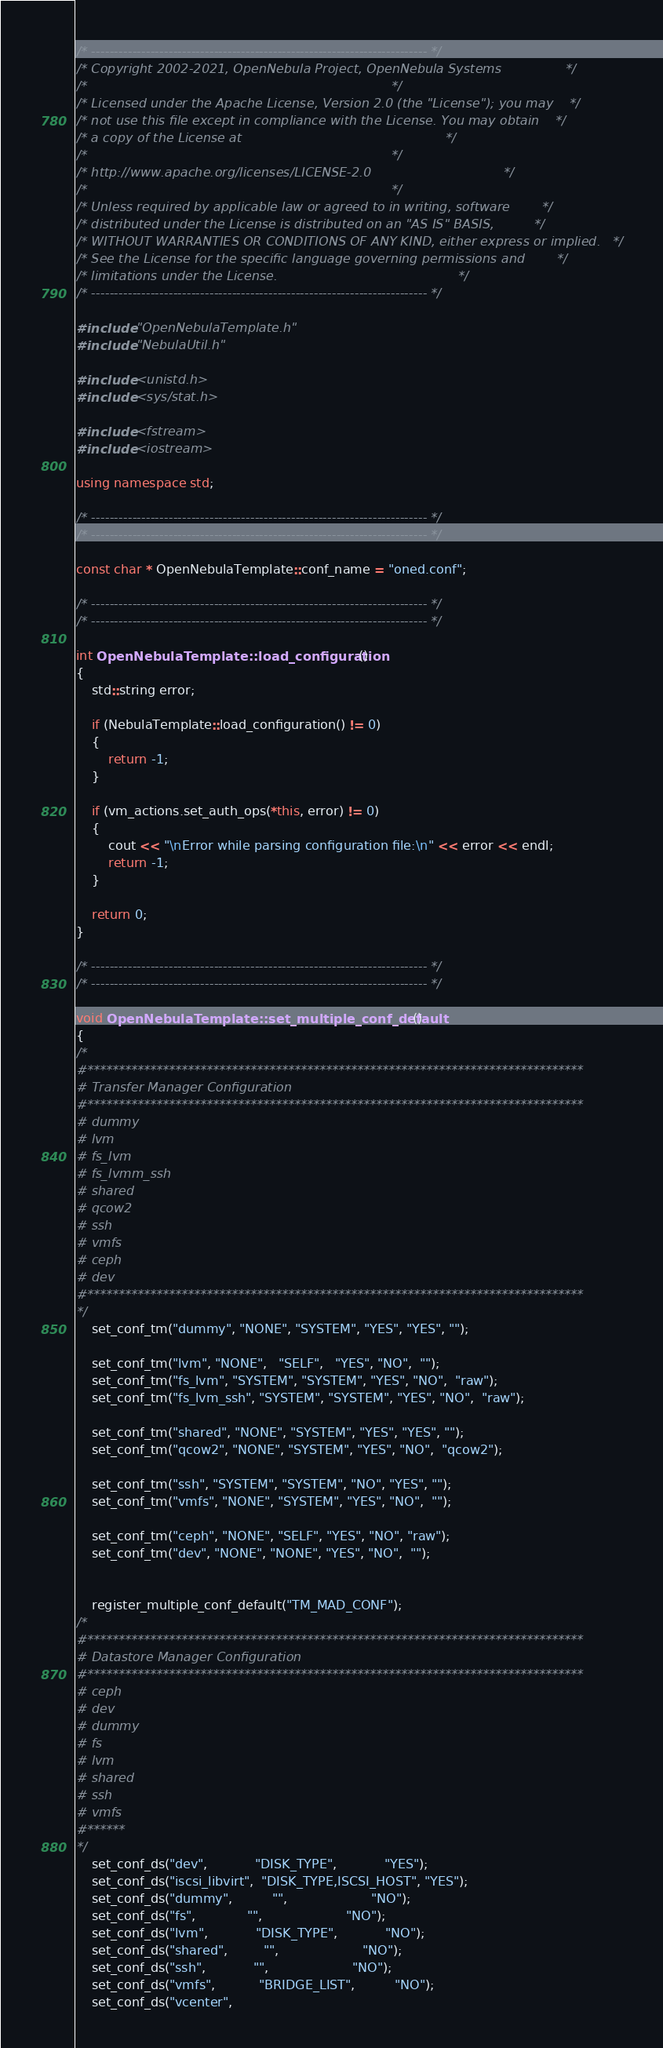Convert code to text. <code><loc_0><loc_0><loc_500><loc_500><_C++_>/* -------------------------------------------------------------------------- */
/* Copyright 2002-2021, OpenNebula Project, OpenNebula Systems                */
/*                                                                            */
/* Licensed under the Apache License, Version 2.0 (the "License"); you may    */
/* not use this file except in compliance with the License. You may obtain    */
/* a copy of the License at                                                   */
/*                                                                            */
/* http://www.apache.org/licenses/LICENSE-2.0                                 */
/*                                                                            */
/* Unless required by applicable law or agreed to in writing, software        */
/* distributed under the License is distributed on an "AS IS" BASIS,          */
/* WITHOUT WARRANTIES OR CONDITIONS OF ANY KIND, either express or implied.   */
/* See the License for the specific language governing permissions and        */
/* limitations under the License.                                             */
/* -------------------------------------------------------------------------- */

#include "OpenNebulaTemplate.h"
#include "NebulaUtil.h"

#include <unistd.h>
#include <sys/stat.h>

#include <fstream>
#include <iostream>

using namespace std;

/* -------------------------------------------------------------------------- */
/* -------------------------------------------------------------------------- */

const char * OpenNebulaTemplate::conf_name = "oned.conf";

/* -------------------------------------------------------------------------- */
/* -------------------------------------------------------------------------- */

int OpenNebulaTemplate::load_configuration()
{
    std::string error;

    if (NebulaTemplate::load_configuration() != 0)
    {
        return -1;
    }

    if (vm_actions.set_auth_ops(*this, error) != 0)
    {
        cout << "\nError while parsing configuration file:\n" << error << endl;
        return -1;
    }

    return 0;
}

/* -------------------------------------------------------------------------- */
/* -------------------------------------------------------------------------- */

void OpenNebulaTemplate::set_multiple_conf_default()
{
/*
#*******************************************************************************
# Transfer Manager Configuration
#*******************************************************************************
# dummy
# lvm
# fs_lvm
# fs_lvmm_ssh
# shared
# qcow2
# ssh
# vmfs
# ceph
# dev
#*******************************************************************************
*/
    set_conf_tm("dummy", "NONE", "SYSTEM", "YES", "YES", "");

    set_conf_tm("lvm", "NONE",   "SELF",   "YES", "NO",  "");
    set_conf_tm("fs_lvm", "SYSTEM", "SYSTEM", "YES", "NO",  "raw");
    set_conf_tm("fs_lvm_ssh", "SYSTEM", "SYSTEM", "YES", "NO",  "raw");

    set_conf_tm("shared", "NONE", "SYSTEM", "YES", "YES", "");
    set_conf_tm("qcow2", "NONE", "SYSTEM", "YES", "NO",  "qcow2");

    set_conf_tm("ssh", "SYSTEM", "SYSTEM", "NO", "YES", "");
    set_conf_tm("vmfs", "NONE", "SYSTEM", "YES", "NO",  "");

    set_conf_tm("ceph", "NONE", "SELF", "YES", "NO", "raw");
    set_conf_tm("dev", "NONE", "NONE", "YES", "NO",  "");


    register_multiple_conf_default("TM_MAD_CONF");
/*
#*******************************************************************************
# Datastore Manager Configuration
#*******************************************************************************
# ceph
# dev
# dummy
# fs
# lvm
# shared
# ssh
# vmfs
#******
*/
    set_conf_ds("dev",            "DISK_TYPE",            "YES");
    set_conf_ds("iscsi_libvirt",  "DISK_TYPE,ISCSI_HOST", "YES");
    set_conf_ds("dummy",          "",                     "NO");
    set_conf_ds("fs",             "",                     "NO");
    set_conf_ds("lvm",            "DISK_TYPE",            "NO");
    set_conf_ds("shared",         "",                     "NO");
    set_conf_ds("ssh",            "",                     "NO");
    set_conf_ds("vmfs",           "BRIDGE_LIST",          "NO");
    set_conf_ds("vcenter",</code> 